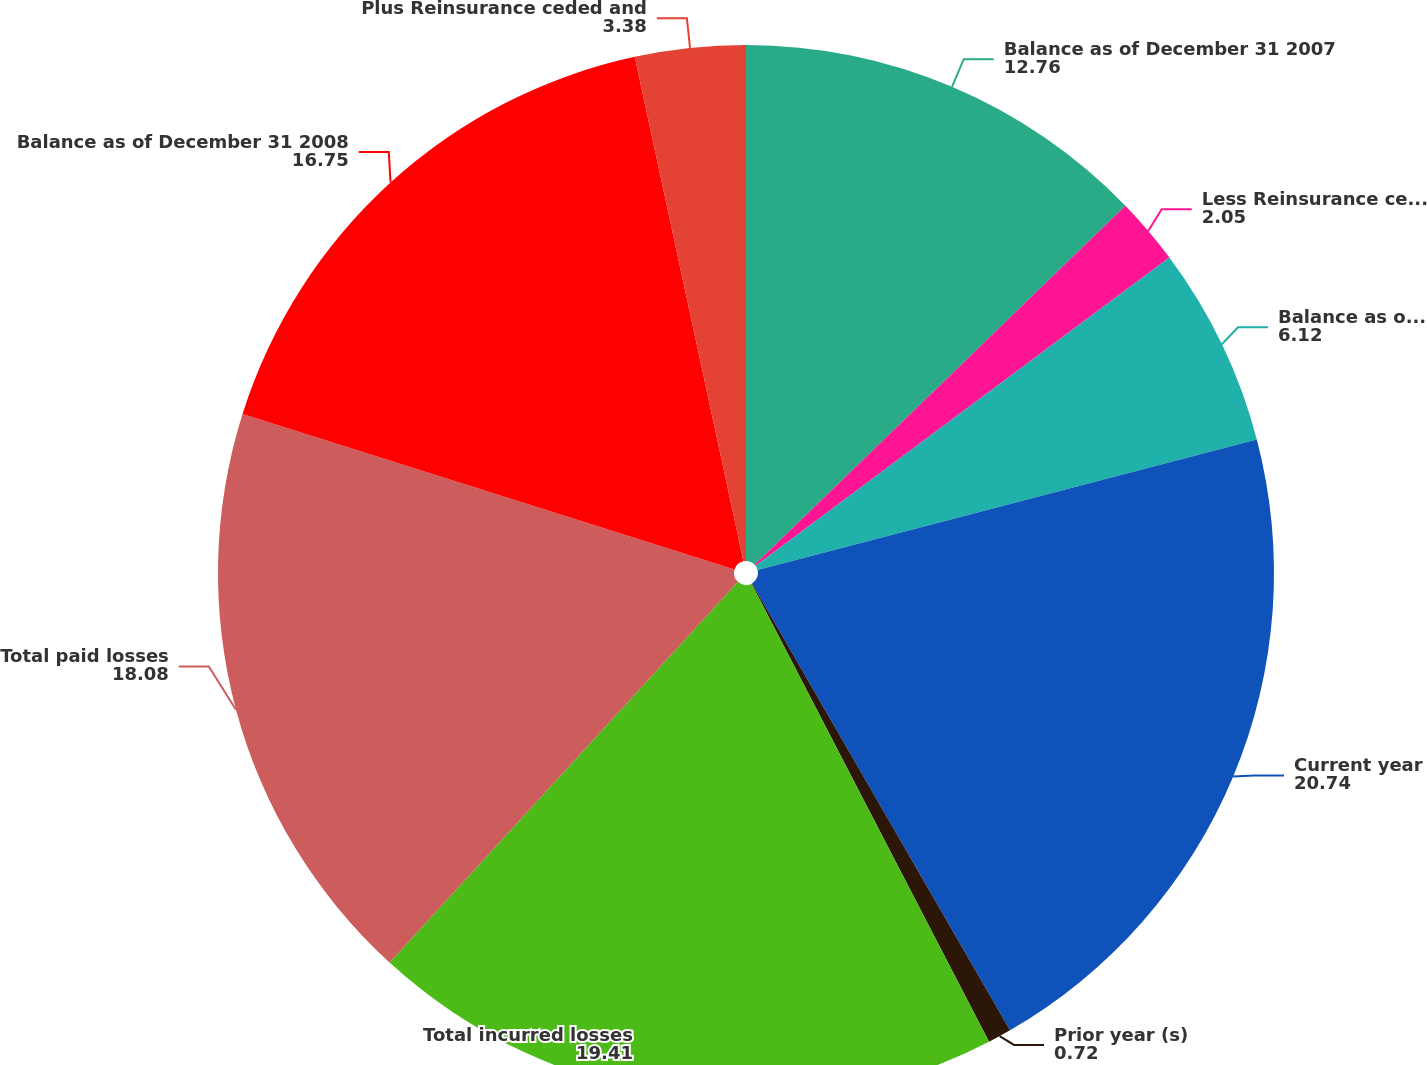Convert chart. <chart><loc_0><loc_0><loc_500><loc_500><pie_chart><fcel>Balance as of December 31 2007<fcel>Less Reinsurance ceded and<fcel>Balance as of January 1 2008<fcel>Current year<fcel>Prior year (s)<fcel>Total incurred losses<fcel>Total paid losses<fcel>Balance as of December 31 2008<fcel>Plus Reinsurance ceded and<nl><fcel>12.76%<fcel>2.05%<fcel>6.12%<fcel>20.74%<fcel>0.72%<fcel>19.41%<fcel>18.08%<fcel>16.75%<fcel>3.38%<nl></chart> 